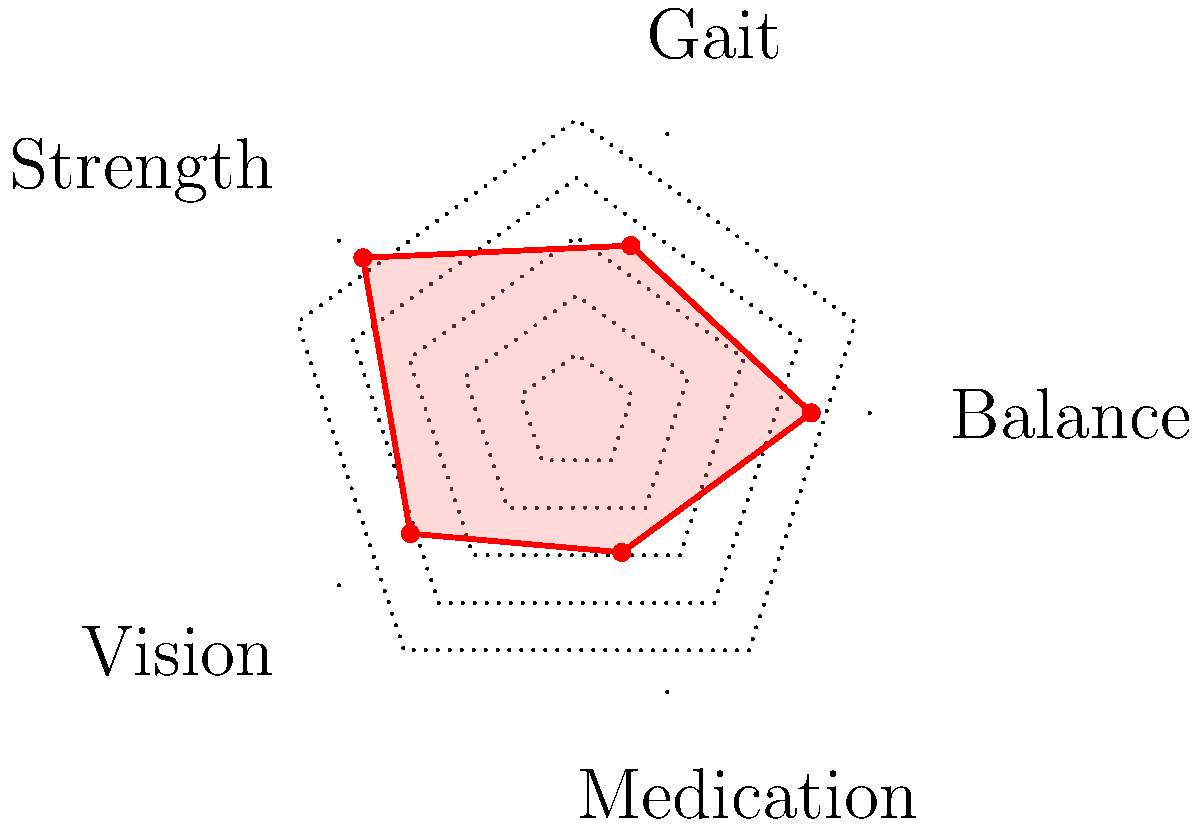Based on the radar chart showing fall risk assessment results for a senior patient, which area indicates the highest risk factor and what immediate intervention should be recommended? To answer this question, we need to analyze the radar chart and follow these steps:

1. Identify the five risk factors assessed: Balance, Gait, Strength, Vision, and Medication.

2. Examine the scale of the chart:
   - The center represents the lowest risk (0)
   - The outer edge represents the highest risk (1)

3. Compare the values for each factor:
   - Balance: 0.8
   - Gait: 0.6
   - Strength: 0.9
   - Vision: 0.7
   - Medication: 0.5

4. Identify the highest risk factor:
   Strength has the highest value at 0.9, indicating it's the area of greatest concern.

5. Determine an appropriate intervention:
   For strength-related fall risks, the immediate recommendation should be to refer the patient to a physical therapist for a strength training program tailored to their needs.

Therefore, the area indicating the highest risk factor is Strength, and the immediate intervention should be a referral to a physical therapist for strength training.
Answer: Strength; refer to physical therapist for strength training 